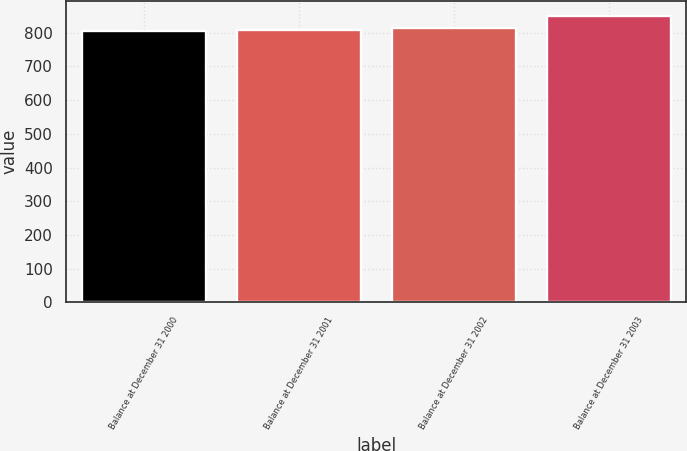Convert chart. <chart><loc_0><loc_0><loc_500><loc_500><bar_chart><fcel>Balance at December 31 2000<fcel>Balance at December 31 2001<fcel>Balance at December 31 2002<fcel>Balance at December 31 2003<nl><fcel>805<fcel>809.6<fcel>814.2<fcel>851<nl></chart> 